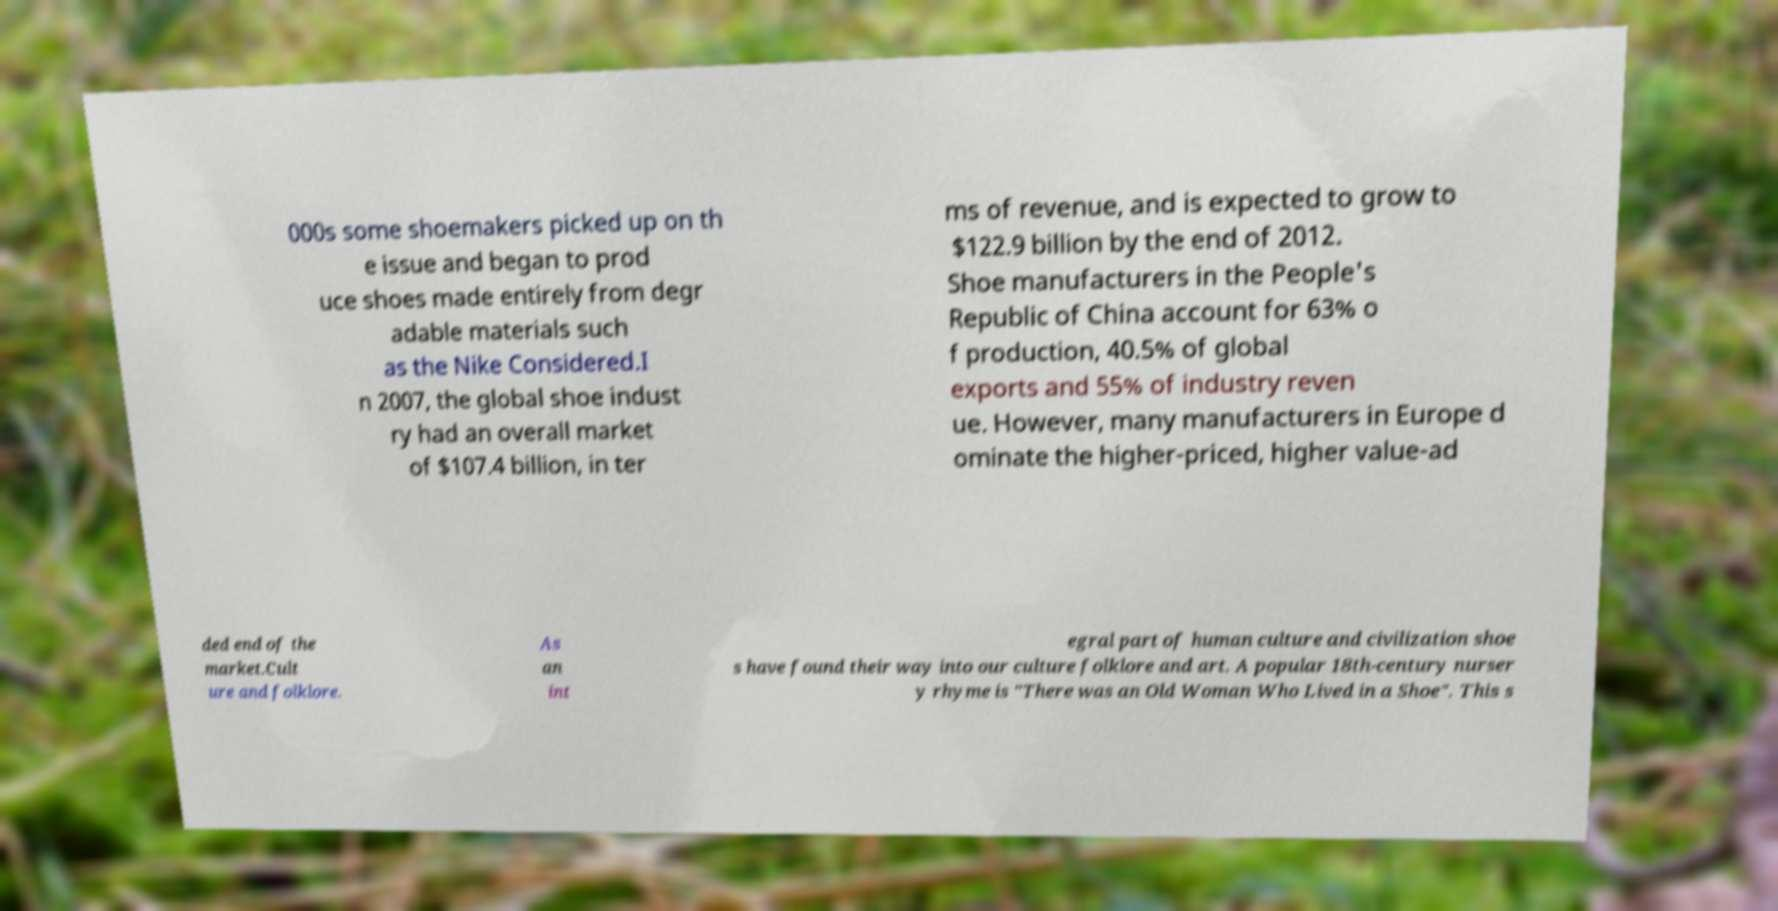Please read and relay the text visible in this image. What does it say? 000s some shoemakers picked up on th e issue and began to prod uce shoes made entirely from degr adable materials such as the Nike Considered.I n 2007, the global shoe indust ry had an overall market of $107.4 billion, in ter ms of revenue, and is expected to grow to $122.9 billion by the end of 2012. Shoe manufacturers in the People's Republic of China account for 63% o f production, 40.5% of global exports and 55% of industry reven ue. However, many manufacturers in Europe d ominate the higher-priced, higher value-ad ded end of the market.Cult ure and folklore. As an int egral part of human culture and civilization shoe s have found their way into our culture folklore and art. A popular 18th-century nurser y rhyme is "There was an Old Woman Who Lived in a Shoe". This s 